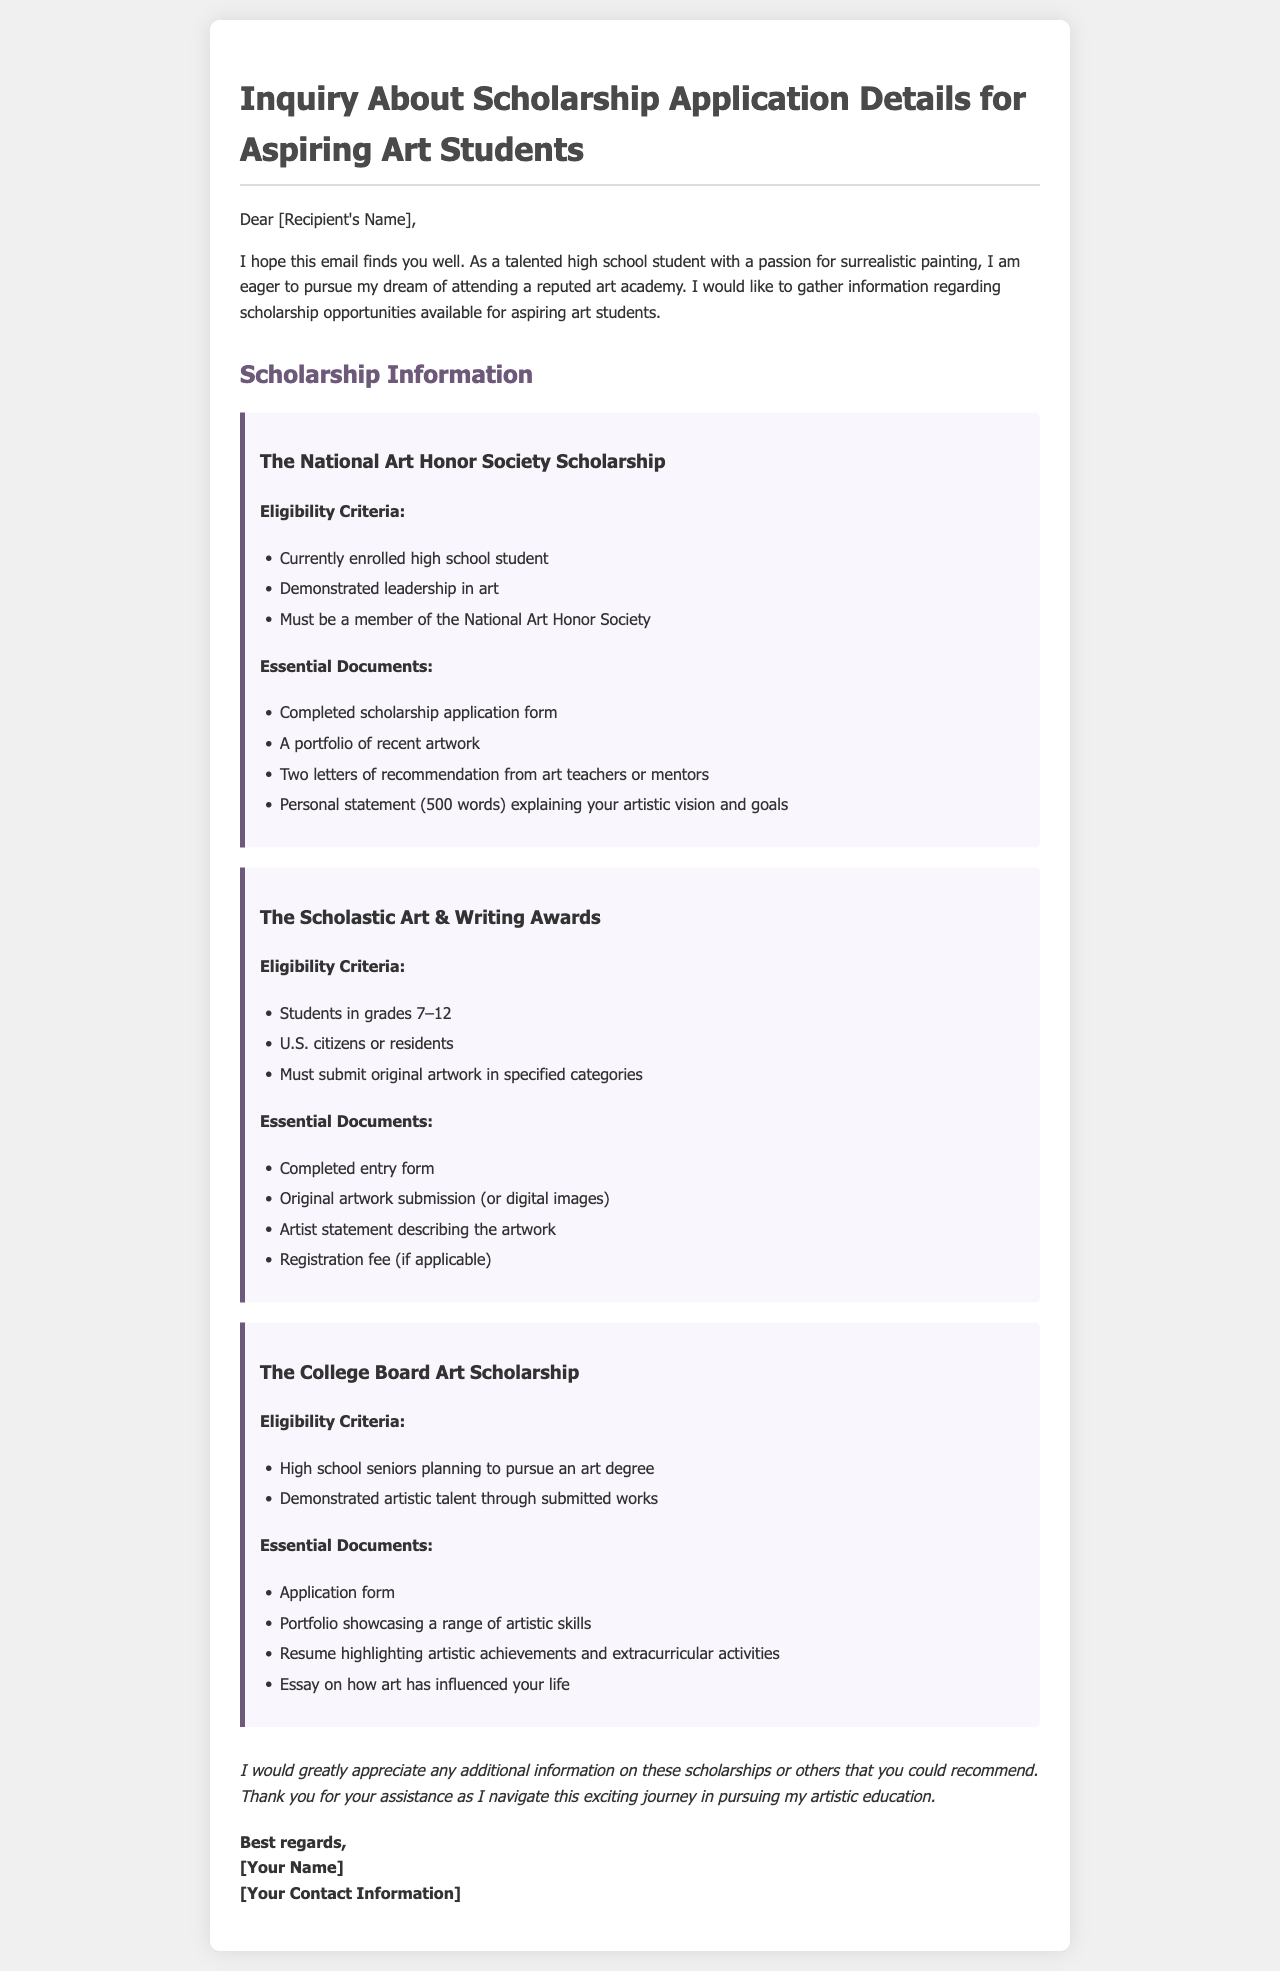What is the name of the first scholarship listed? The first scholarship mentioned in the document is "The National Art Honor Society Scholarship."
Answer: The National Art Honor Society Scholarship Who is eligible for the College Board Art Scholarship? Eligibility for the College Board Art Scholarship includes "High school seniors planning to pursue an art degree."
Answer: High school seniors planning to pursue an art degree What is one essential document required for the Scholastic Art & Writing Awards? One essential document required is "Completed entry form."
Answer: Completed entry form How many letters of recommendation are needed for the National Art Honor Society Scholarship? The document specifies that two letters of recommendation from art teachers or mentors are required.
Answer: Two letters of recommendation What is the maximum number of words for the personal statement in the National Art Honor Society Scholarship? The personal statement must be "500 words" long.
Answer: 500 words What is a common requirement across all scholarships listed in the document? A common requirement is the submission of a portfolio or original artwork.
Answer: Submission of a portfolio or original artwork Which scholarship requires an artist statement describing the artwork? The Scholastic Art & Writing Awards require an artist statement.
Answer: The Scholastic Art & Writing Awards What should the resume for the College Board Art Scholarship highlight? The resume should highlight "artistic achievements and extracurricular activities."
Answer: Artistic achievements and extracurricular activities 